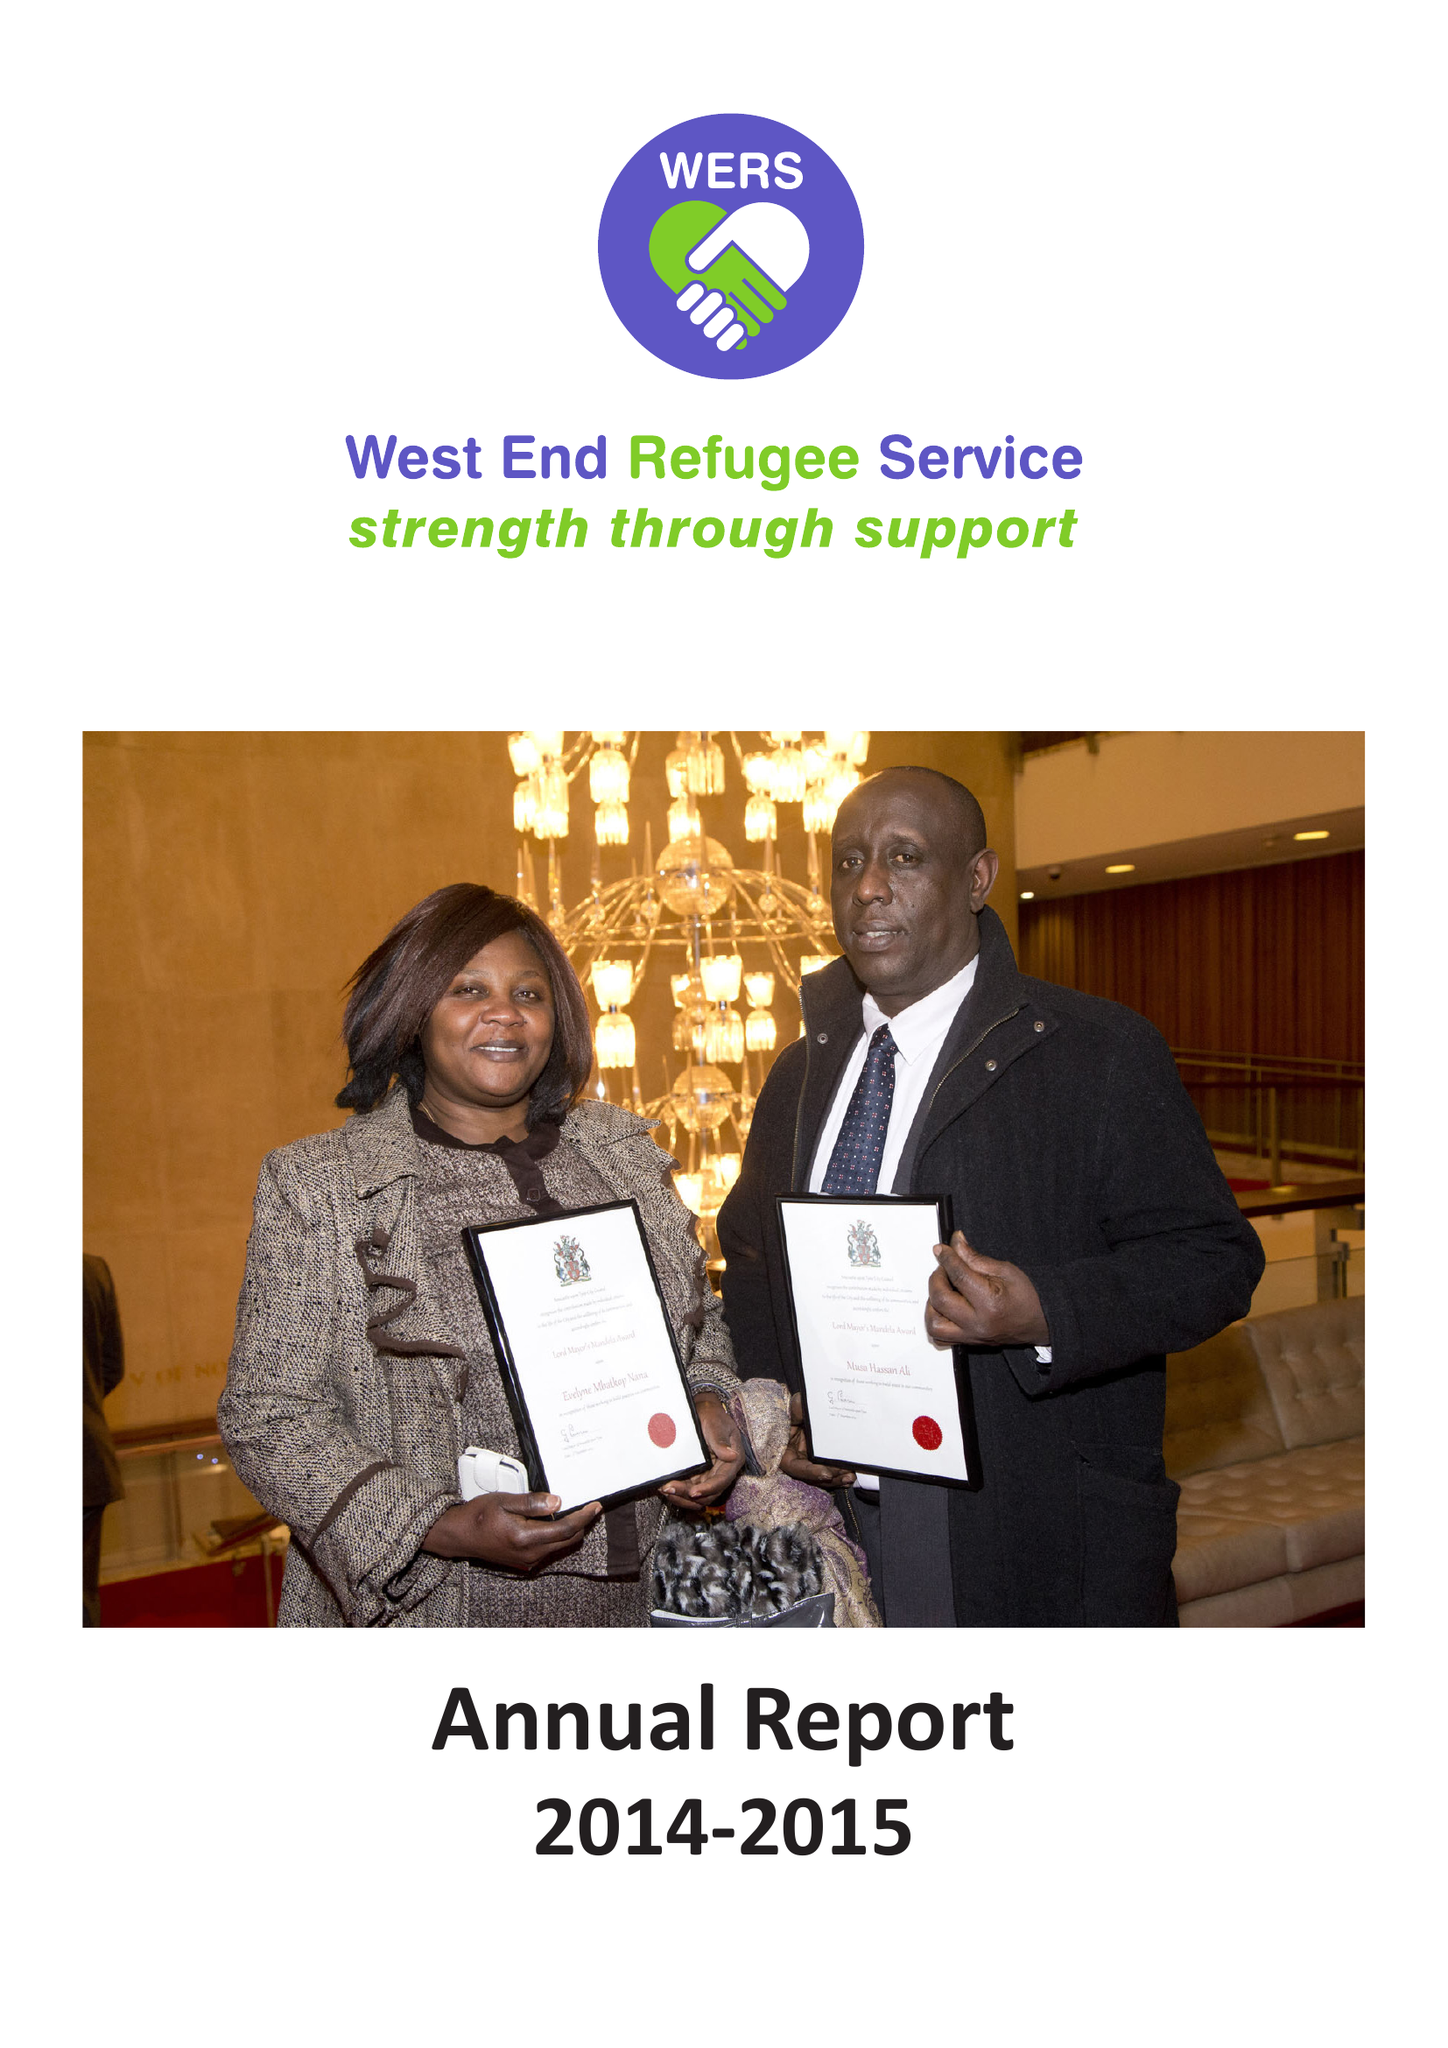What is the value for the address__street_line?
Answer the question using a single word or phrase. ST. PHILIPS CLOSE 